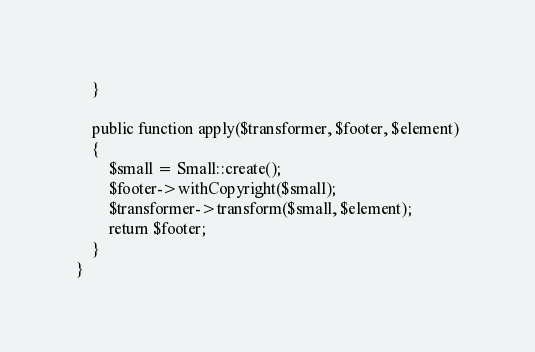<code> <loc_0><loc_0><loc_500><loc_500><_PHP_>    }

    public function apply($transformer, $footer, $element)
    {
        $small = Small::create();
        $footer->withCopyright($small);
        $transformer->transform($small, $element);
        return $footer;
    }
}
</code> 